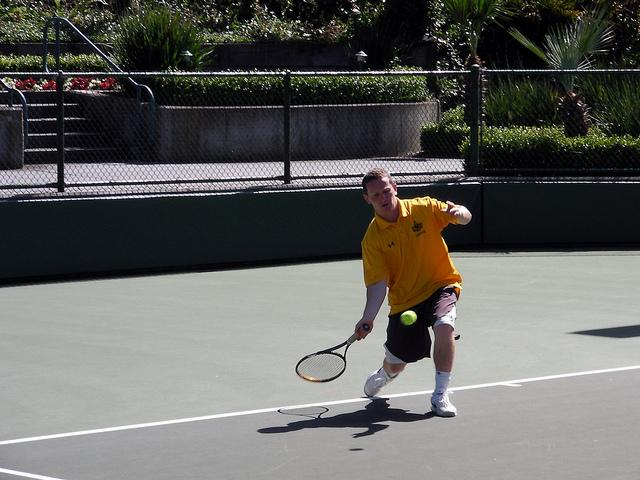What is the man attempting to do with the ball?

Choices:
A) grab it
B) hit it
C) punch it
D) kick it hit it 